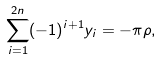Convert formula to latex. <formula><loc_0><loc_0><loc_500><loc_500>\sum _ { i = 1 } ^ { 2 n } ( - 1 ) ^ { i + 1 } y _ { i } = - \pi \rho , \,</formula> 